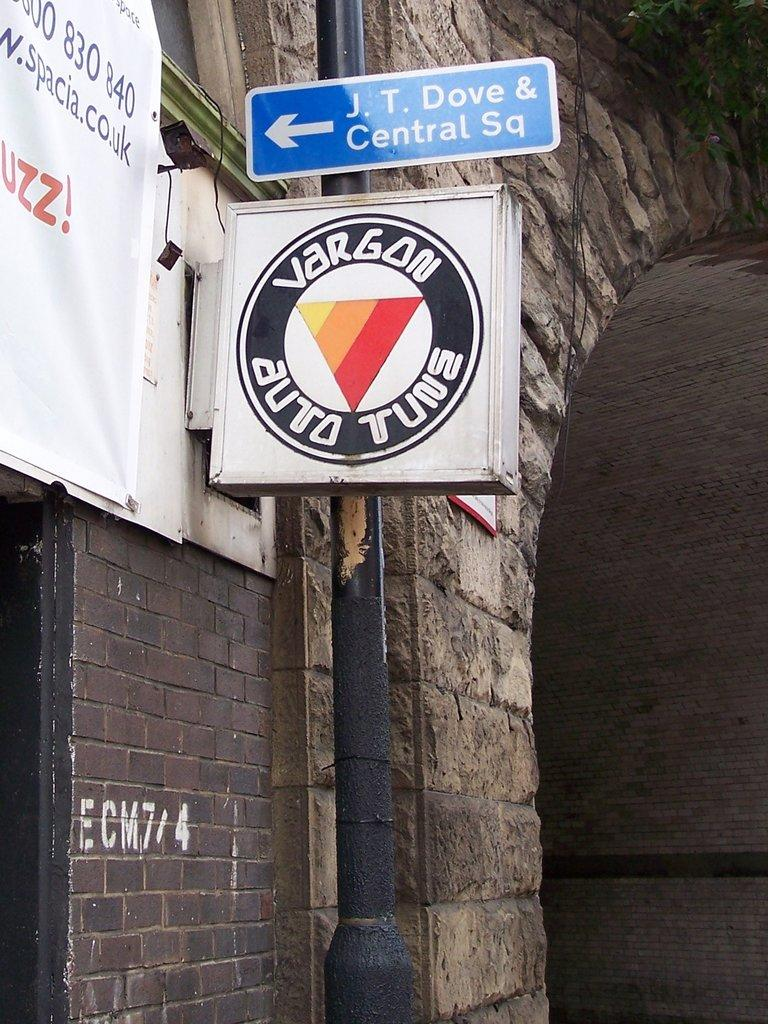<image>
Render a clear and concise summary of the photo. a wall on which is a sign reading Vargon Auto Tune. 